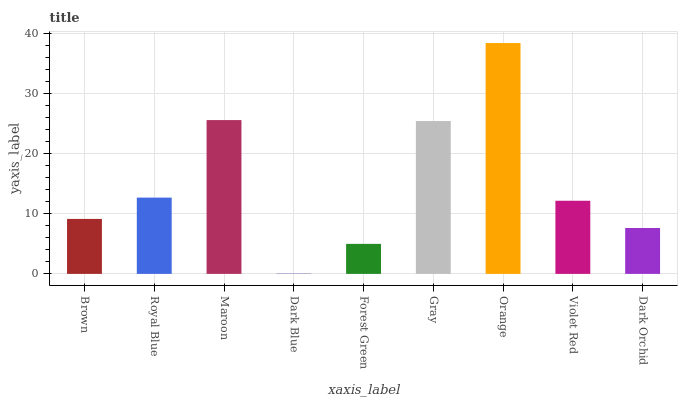Is Dark Blue the minimum?
Answer yes or no. Yes. Is Orange the maximum?
Answer yes or no. Yes. Is Royal Blue the minimum?
Answer yes or no. No. Is Royal Blue the maximum?
Answer yes or no. No. Is Royal Blue greater than Brown?
Answer yes or no. Yes. Is Brown less than Royal Blue?
Answer yes or no. Yes. Is Brown greater than Royal Blue?
Answer yes or no. No. Is Royal Blue less than Brown?
Answer yes or no. No. Is Violet Red the high median?
Answer yes or no. Yes. Is Violet Red the low median?
Answer yes or no. Yes. Is Gray the high median?
Answer yes or no. No. Is Orange the low median?
Answer yes or no. No. 